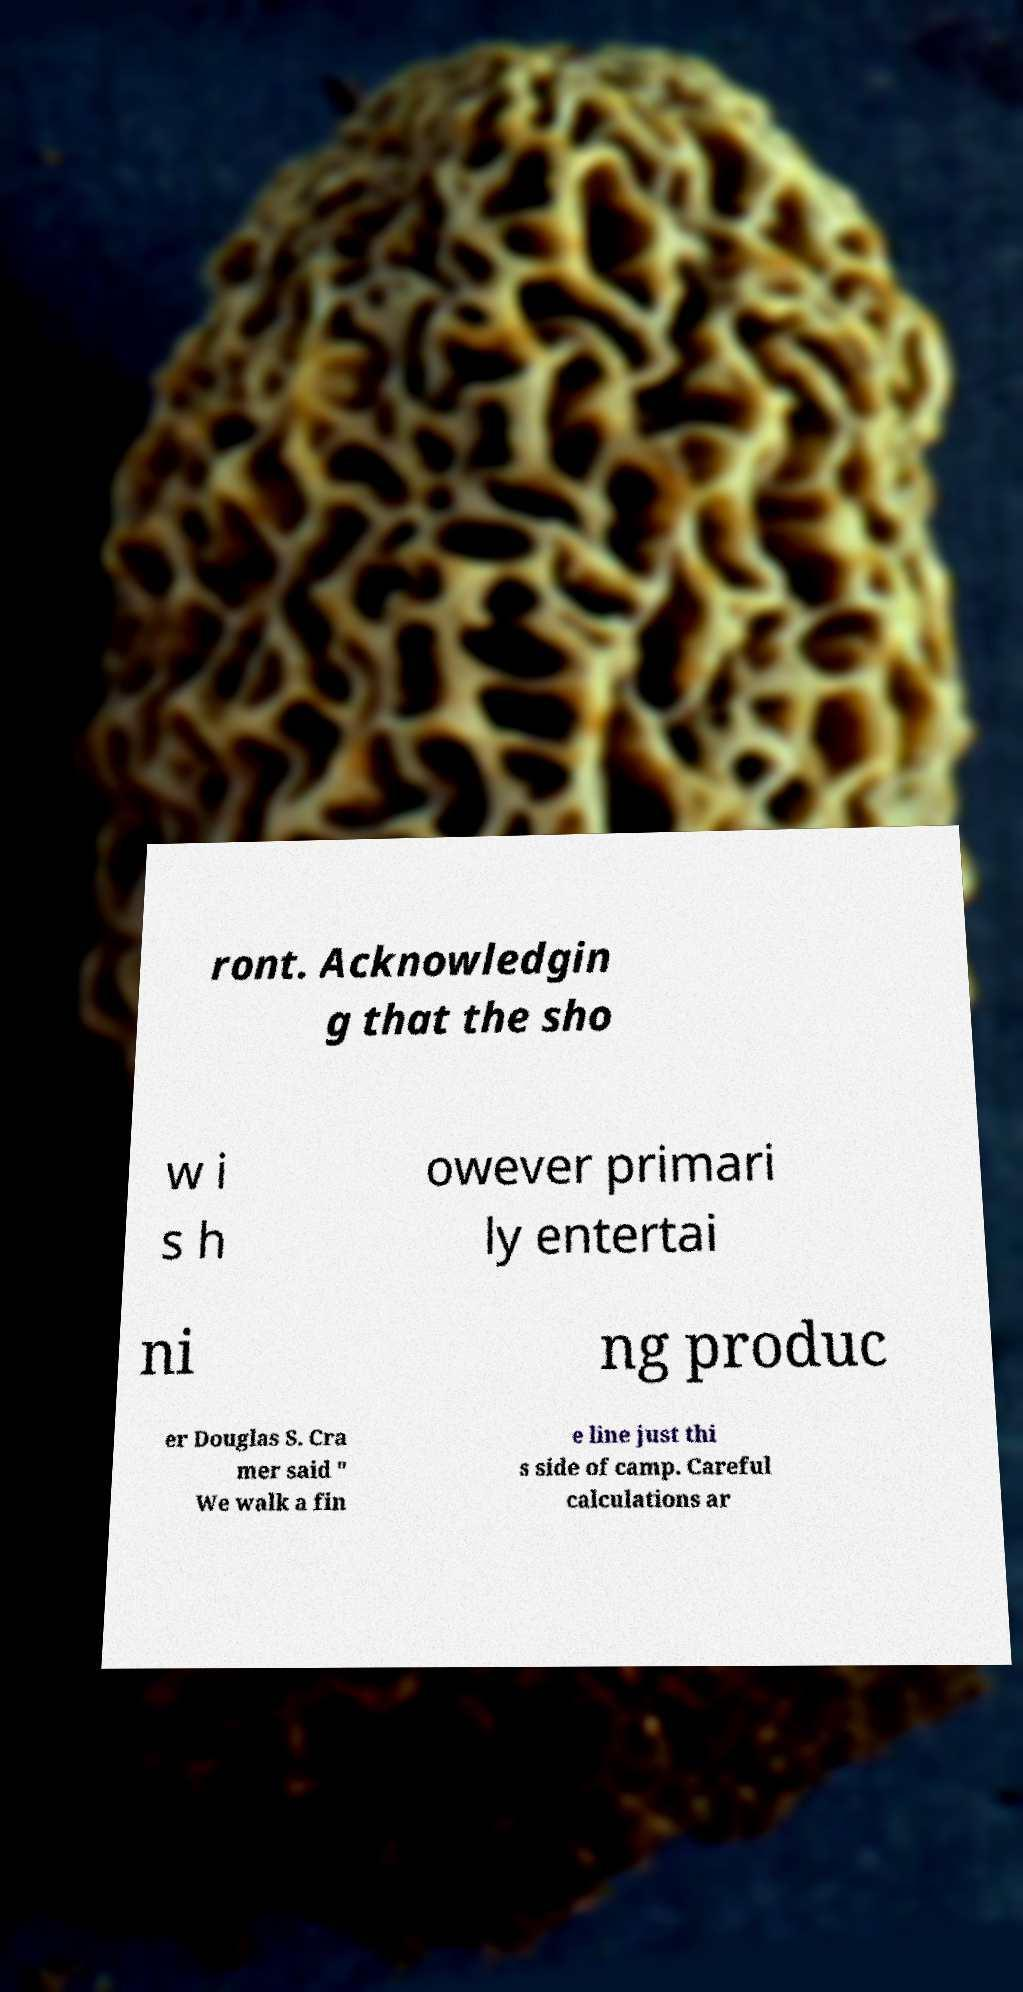For documentation purposes, I need the text within this image transcribed. Could you provide that? ront. Acknowledgin g that the sho w i s h owever primari ly entertai ni ng produc er Douglas S. Cra mer said " We walk a fin e line just thi s side of camp. Careful calculations ar 